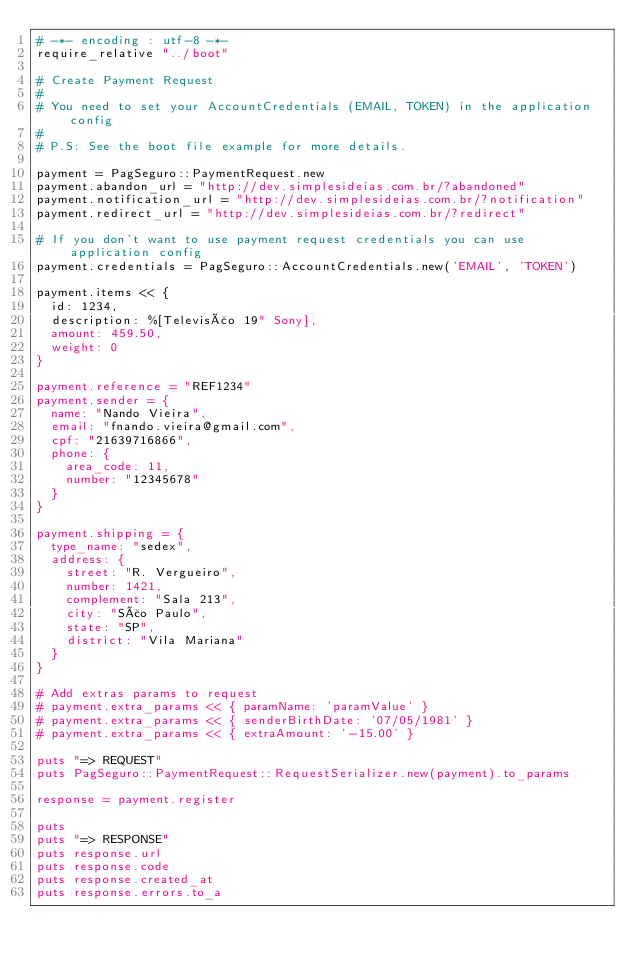Convert code to text. <code><loc_0><loc_0><loc_500><loc_500><_Ruby_># -*- encoding : utf-8 -*-
require_relative "../boot"

# Create Payment Request
#
# You need to set your AccountCredentials (EMAIL, TOKEN) in the application config
#
# P.S: See the boot file example for more details.

payment = PagSeguro::PaymentRequest.new
payment.abandon_url = "http://dev.simplesideias.com.br/?abandoned"
payment.notification_url = "http://dev.simplesideias.com.br/?notification"
payment.redirect_url = "http://dev.simplesideias.com.br/?redirect"

# If you don't want to use payment request credentials you can use application config
payment.credentials = PagSeguro::AccountCredentials.new('EMAIL', 'TOKEN')

payment.items << {
  id: 1234,
  description: %[Televisão 19" Sony],
  amount: 459.50,
  weight: 0
}

payment.reference = "REF1234"
payment.sender = {
  name: "Nando Vieira",
  email: "fnando.vieira@gmail.com",
  cpf: "21639716866",
  phone: {
    area_code: 11,
    number: "12345678"
  }
}

payment.shipping = {
  type_name: "sedex",
  address: {
    street: "R. Vergueiro",
    number: 1421,
    complement: "Sala 213",
    city: "São Paulo",
    state: "SP",
    district: "Vila Mariana"
  }
}

# Add extras params to request
# payment.extra_params << { paramName: 'paramValue' }
# payment.extra_params << { senderBirthDate: '07/05/1981' }
# payment.extra_params << { extraAmount: '-15.00' }

puts "=> REQUEST"
puts PagSeguro::PaymentRequest::RequestSerializer.new(payment).to_params

response = payment.register

puts
puts "=> RESPONSE"
puts response.url
puts response.code
puts response.created_at
puts response.errors.to_a
</code> 